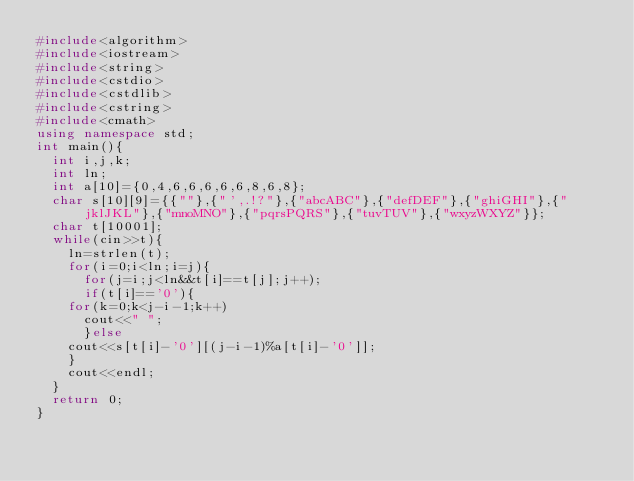<code> <loc_0><loc_0><loc_500><loc_500><_C++_>#include<algorithm>
#include<iostream>
#include<string>
#include<cstdio>
#include<cstdlib>
#include<cstring>
#include<cmath>
using namespace std;
int main(){
  int i,j,k;
  int ln;
  int a[10]={0,4,6,6,6,6,6,8,6,8};
  char s[10][9]={{""},{"',.!?"},{"abcABC"},{"defDEF"},{"ghiGHI"},{"jklJKL"},{"mnoMNO"},{"pqrsPQRS"},{"tuvTUV"},{"wxyzWXYZ"}};
  char t[10001];
  while(cin>>t){
    ln=strlen(t);
    for(i=0;i<ln;i=j){
      for(j=i;j<ln&&t[i]==t[j];j++);
      if(t[i]=='0'){
	for(k=0;k<j-i-1;k++)
	  cout<<" ";
      }else
	cout<<s[t[i]-'0'][(j-i-1)%a[t[i]-'0']];
    }
    cout<<endl;
  }
  return 0;
}</code> 